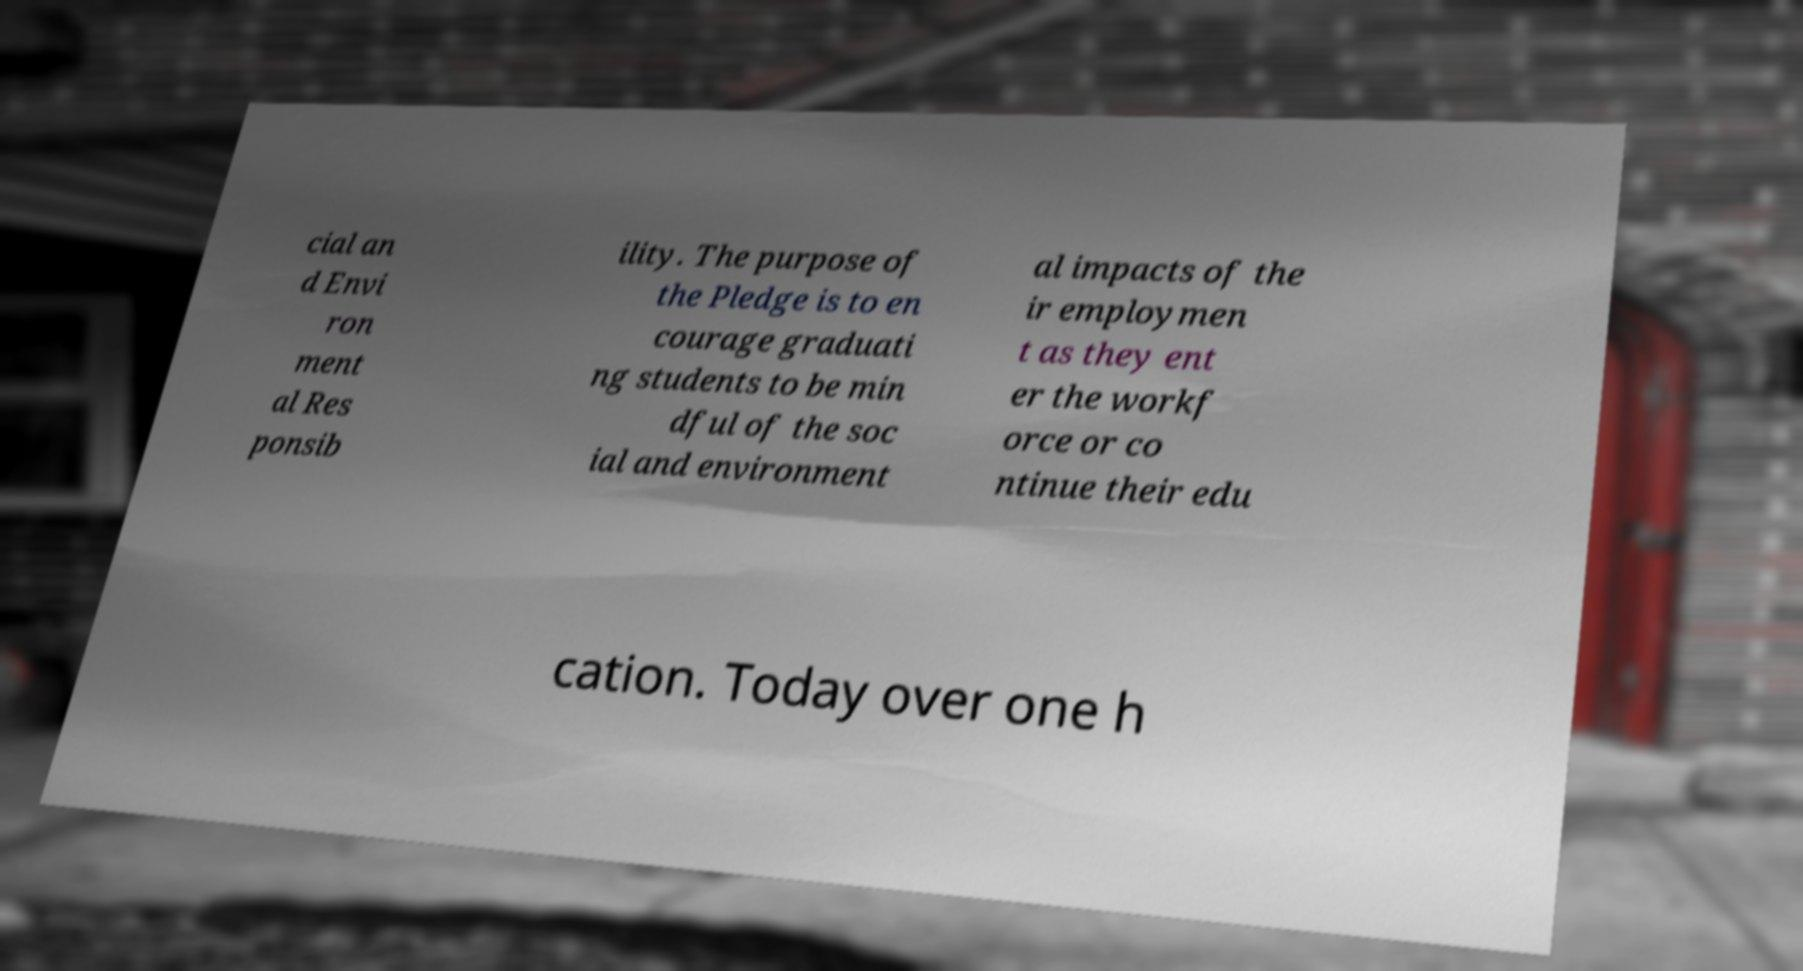Can you accurately transcribe the text from the provided image for me? cial an d Envi ron ment al Res ponsib ility. The purpose of the Pledge is to en courage graduati ng students to be min dful of the soc ial and environment al impacts of the ir employmen t as they ent er the workf orce or co ntinue their edu cation. Today over one h 